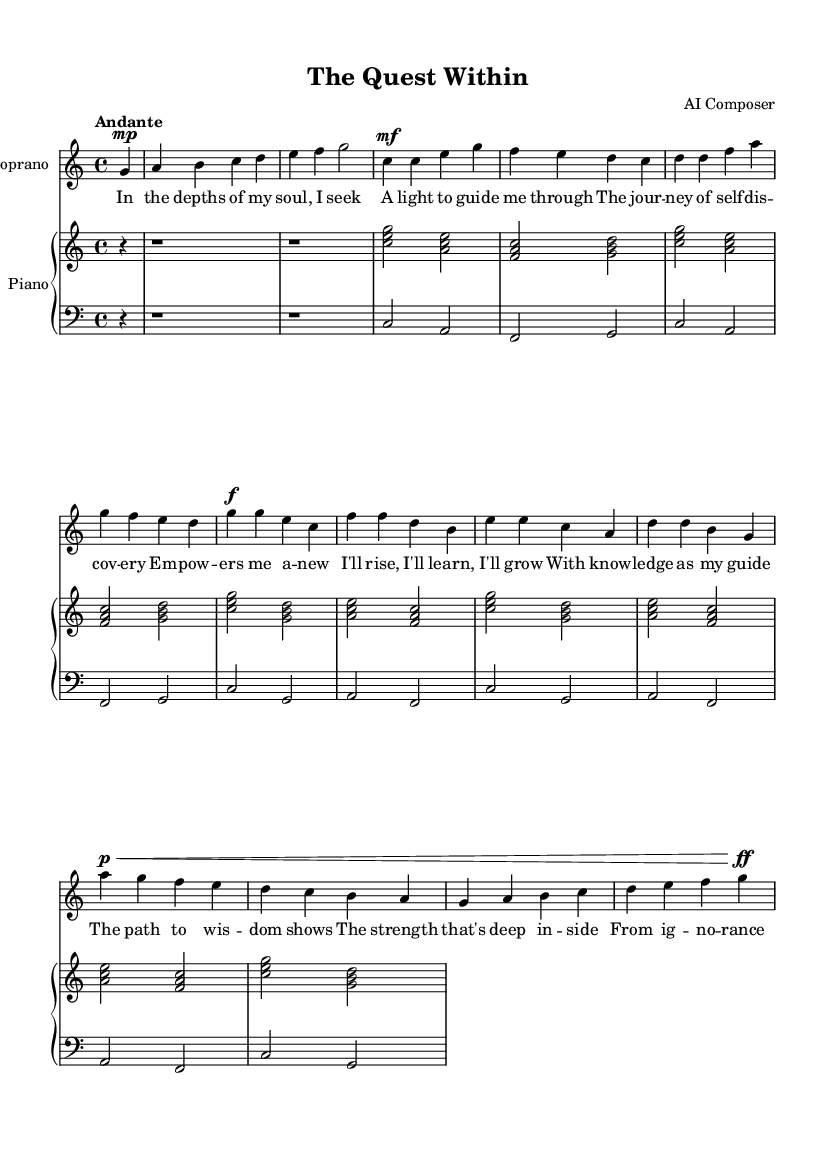What is the key signature of this music? The key signature in the score is C major, which has no sharps or flats indicated.
Answer: C major What is the time signature of this piece? The time signature is indicated at the beginning of the score and is 4/4, which means there are four beats in each measure.
Answer: 4/4 What is the tempo marking of this opera? The tempo marking is found at the beginning, stating "Andante", which indicates a moderately slow tempo.
Answer: Andante How many sections are there in the composition? Analyzing the structure, there are three distinct sections: the introduction, the chorus, and the bridge.
Answer: Three What type of music does this sheet represent? This piece falls under the genre of opera, characterized by its dramatic singing and storytelling through music.
Answer: Opera In what part of the piece does the phrase "I'll rise, I'll learn, I'll grow" occur? That phrase is found in the chorus section of the music, which emphasizes personal empowerment.
Answer: Chorus What dynamic marking is used at the beginning of the bridge? The dynamic marking at the beginning of the bridge is piano, indicated by "p," which means to play softly.
Answer: Piano 